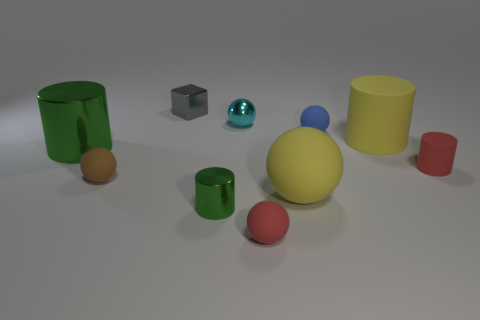Are there any green objects that have the same size as the yellow rubber cylinder? Yes, the green cup appears to be of a similar size to the yellow cylinder, although exact measurements cannot be determined from the image. 